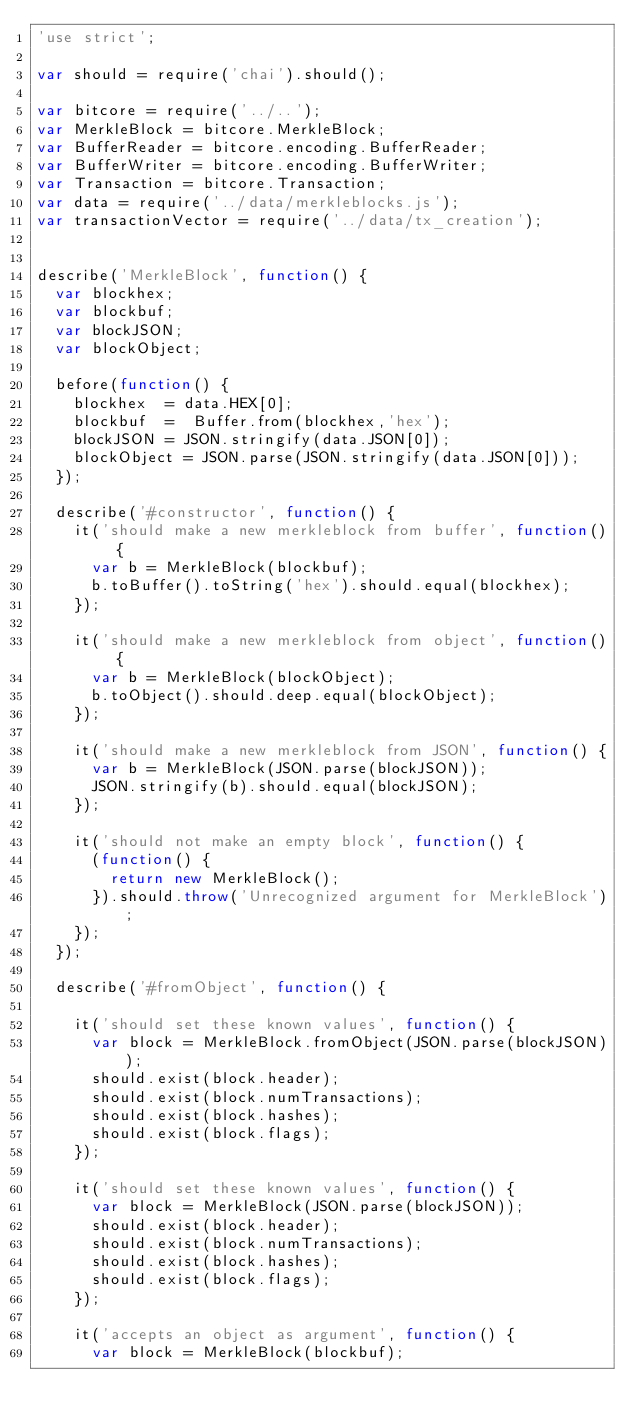Convert code to text. <code><loc_0><loc_0><loc_500><loc_500><_JavaScript_>'use strict';

var should = require('chai').should();

var bitcore = require('../..');
var MerkleBlock = bitcore.MerkleBlock;
var BufferReader = bitcore.encoding.BufferReader;
var BufferWriter = bitcore.encoding.BufferWriter;
var Transaction = bitcore.Transaction;
var data = require('../data/merkleblocks.js');
var transactionVector = require('../data/tx_creation');


describe('MerkleBlock', function() {
  var blockhex;
  var blockbuf;
  var blockJSON;
  var blockObject;

  before(function() {
    blockhex  = data.HEX[0];
    blockbuf  =  Buffer.from(blockhex,'hex');
    blockJSON = JSON.stringify(data.JSON[0]);
    blockObject = JSON.parse(JSON.stringify(data.JSON[0]));
  });

  describe('#constructor', function() {
    it('should make a new merkleblock from buffer', function() {
      var b = MerkleBlock(blockbuf);
      b.toBuffer().toString('hex').should.equal(blockhex);
    });

    it('should make a new merkleblock from object', function() {
      var b = MerkleBlock(blockObject);
      b.toObject().should.deep.equal(blockObject);
    });

    it('should make a new merkleblock from JSON', function() {
      var b = MerkleBlock(JSON.parse(blockJSON));
      JSON.stringify(b).should.equal(blockJSON);
    });

    it('should not make an empty block', function() {
      (function() {
        return new MerkleBlock();
      }).should.throw('Unrecognized argument for MerkleBlock');
    });
  });

  describe('#fromObject', function() {

    it('should set these known values', function() {
      var block = MerkleBlock.fromObject(JSON.parse(blockJSON));
      should.exist(block.header);
      should.exist(block.numTransactions);
      should.exist(block.hashes);
      should.exist(block.flags);
    });

    it('should set these known values', function() {
      var block = MerkleBlock(JSON.parse(blockJSON));
      should.exist(block.header);
      should.exist(block.numTransactions);
      should.exist(block.hashes);
      should.exist(block.flags);
    });

    it('accepts an object as argument', function() {
      var block = MerkleBlock(blockbuf);</code> 